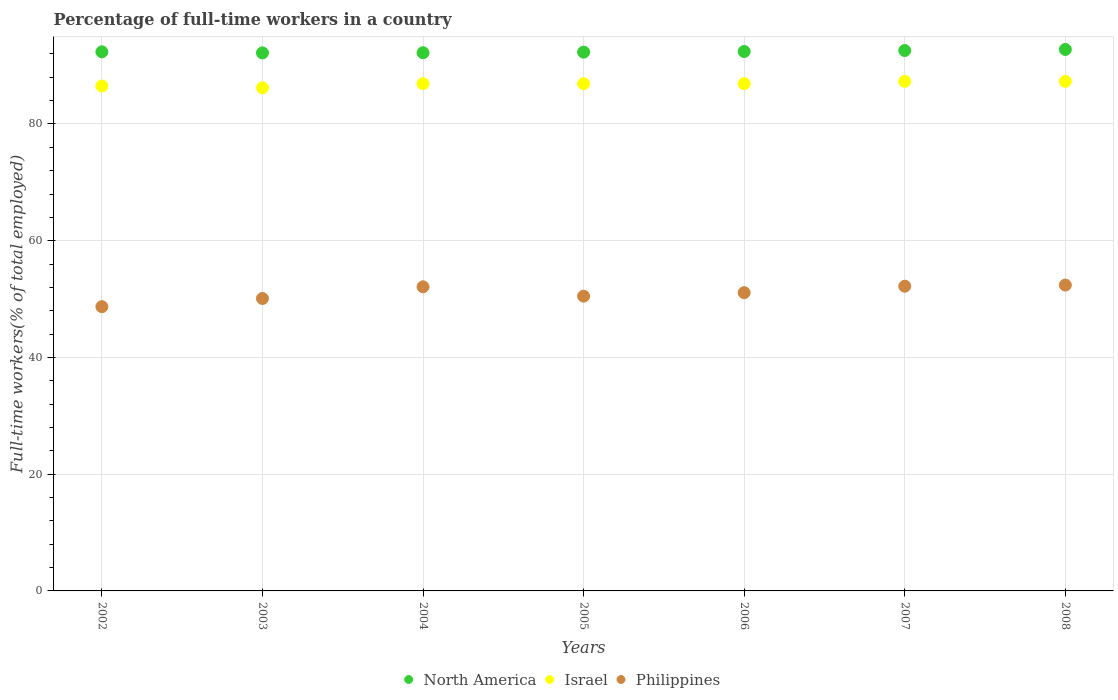Is the number of dotlines equal to the number of legend labels?
Offer a terse response. Yes. What is the percentage of full-time workers in North America in 2007?
Provide a short and direct response. 92.58. Across all years, what is the maximum percentage of full-time workers in Israel?
Your answer should be very brief. 87.3. Across all years, what is the minimum percentage of full-time workers in Philippines?
Keep it short and to the point. 48.7. In which year was the percentage of full-time workers in Israel minimum?
Make the answer very short. 2003. What is the total percentage of full-time workers in Israel in the graph?
Make the answer very short. 608. What is the difference between the percentage of full-time workers in Philippines in 2006 and that in 2007?
Your answer should be compact. -1.1. What is the difference between the percentage of full-time workers in North America in 2004 and the percentage of full-time workers in Israel in 2008?
Ensure brevity in your answer.  4.9. What is the average percentage of full-time workers in Philippines per year?
Give a very brief answer. 51.01. In the year 2003, what is the difference between the percentage of full-time workers in North America and percentage of full-time workers in Israel?
Give a very brief answer. 5.97. What is the ratio of the percentage of full-time workers in Philippines in 2003 to that in 2007?
Offer a terse response. 0.96. What is the difference between the highest and the second highest percentage of full-time workers in Israel?
Make the answer very short. 0. What is the difference between the highest and the lowest percentage of full-time workers in Israel?
Ensure brevity in your answer.  1.1. Is the sum of the percentage of full-time workers in Israel in 2004 and 2007 greater than the maximum percentage of full-time workers in Philippines across all years?
Your answer should be very brief. Yes. How many dotlines are there?
Offer a terse response. 3. How many years are there in the graph?
Offer a terse response. 7. What is the difference between two consecutive major ticks on the Y-axis?
Your response must be concise. 20. Are the values on the major ticks of Y-axis written in scientific E-notation?
Provide a succinct answer. No. Does the graph contain any zero values?
Offer a terse response. No. Where does the legend appear in the graph?
Keep it short and to the point. Bottom center. How many legend labels are there?
Offer a very short reply. 3. What is the title of the graph?
Keep it short and to the point. Percentage of full-time workers in a country. What is the label or title of the Y-axis?
Offer a terse response. Full-time workers(% of total employed). What is the Full-time workers(% of total employed) of North America in 2002?
Provide a short and direct response. 92.36. What is the Full-time workers(% of total employed) in Israel in 2002?
Your response must be concise. 86.5. What is the Full-time workers(% of total employed) of Philippines in 2002?
Your response must be concise. 48.7. What is the Full-time workers(% of total employed) of North America in 2003?
Give a very brief answer. 92.17. What is the Full-time workers(% of total employed) of Israel in 2003?
Keep it short and to the point. 86.2. What is the Full-time workers(% of total employed) of Philippines in 2003?
Offer a very short reply. 50.1. What is the Full-time workers(% of total employed) of North America in 2004?
Provide a succinct answer. 92.2. What is the Full-time workers(% of total employed) in Israel in 2004?
Offer a very short reply. 86.9. What is the Full-time workers(% of total employed) in Philippines in 2004?
Offer a terse response. 52.1. What is the Full-time workers(% of total employed) of North America in 2005?
Ensure brevity in your answer.  92.31. What is the Full-time workers(% of total employed) in Israel in 2005?
Your response must be concise. 86.9. What is the Full-time workers(% of total employed) of Philippines in 2005?
Your answer should be very brief. 50.5. What is the Full-time workers(% of total employed) in North America in 2006?
Keep it short and to the point. 92.42. What is the Full-time workers(% of total employed) of Israel in 2006?
Your answer should be compact. 86.9. What is the Full-time workers(% of total employed) in Philippines in 2006?
Give a very brief answer. 51.1. What is the Full-time workers(% of total employed) in North America in 2007?
Your answer should be compact. 92.58. What is the Full-time workers(% of total employed) of Israel in 2007?
Offer a terse response. 87.3. What is the Full-time workers(% of total employed) in Philippines in 2007?
Keep it short and to the point. 52.2. What is the Full-time workers(% of total employed) of North America in 2008?
Offer a terse response. 92.77. What is the Full-time workers(% of total employed) of Israel in 2008?
Your answer should be very brief. 87.3. What is the Full-time workers(% of total employed) of Philippines in 2008?
Give a very brief answer. 52.4. Across all years, what is the maximum Full-time workers(% of total employed) in North America?
Provide a short and direct response. 92.77. Across all years, what is the maximum Full-time workers(% of total employed) in Israel?
Your response must be concise. 87.3. Across all years, what is the maximum Full-time workers(% of total employed) in Philippines?
Provide a short and direct response. 52.4. Across all years, what is the minimum Full-time workers(% of total employed) in North America?
Ensure brevity in your answer.  92.17. Across all years, what is the minimum Full-time workers(% of total employed) of Israel?
Give a very brief answer. 86.2. Across all years, what is the minimum Full-time workers(% of total employed) in Philippines?
Your response must be concise. 48.7. What is the total Full-time workers(% of total employed) of North America in the graph?
Keep it short and to the point. 646.81. What is the total Full-time workers(% of total employed) of Israel in the graph?
Provide a short and direct response. 608. What is the total Full-time workers(% of total employed) of Philippines in the graph?
Your response must be concise. 357.1. What is the difference between the Full-time workers(% of total employed) in North America in 2002 and that in 2003?
Your answer should be very brief. 0.18. What is the difference between the Full-time workers(% of total employed) in Israel in 2002 and that in 2003?
Give a very brief answer. 0.3. What is the difference between the Full-time workers(% of total employed) in North America in 2002 and that in 2004?
Your answer should be compact. 0.15. What is the difference between the Full-time workers(% of total employed) in Philippines in 2002 and that in 2004?
Give a very brief answer. -3.4. What is the difference between the Full-time workers(% of total employed) in North America in 2002 and that in 2005?
Your response must be concise. 0.05. What is the difference between the Full-time workers(% of total employed) of Israel in 2002 and that in 2005?
Your answer should be very brief. -0.4. What is the difference between the Full-time workers(% of total employed) of Philippines in 2002 and that in 2005?
Provide a short and direct response. -1.8. What is the difference between the Full-time workers(% of total employed) in North America in 2002 and that in 2006?
Provide a short and direct response. -0.06. What is the difference between the Full-time workers(% of total employed) of Philippines in 2002 and that in 2006?
Your response must be concise. -2.4. What is the difference between the Full-time workers(% of total employed) in North America in 2002 and that in 2007?
Ensure brevity in your answer.  -0.22. What is the difference between the Full-time workers(% of total employed) of Israel in 2002 and that in 2007?
Offer a very short reply. -0.8. What is the difference between the Full-time workers(% of total employed) of Philippines in 2002 and that in 2007?
Your answer should be compact. -3.5. What is the difference between the Full-time workers(% of total employed) in North America in 2002 and that in 2008?
Ensure brevity in your answer.  -0.41. What is the difference between the Full-time workers(% of total employed) in Israel in 2002 and that in 2008?
Your answer should be compact. -0.8. What is the difference between the Full-time workers(% of total employed) in North America in 2003 and that in 2004?
Your response must be concise. -0.03. What is the difference between the Full-time workers(% of total employed) in North America in 2003 and that in 2005?
Give a very brief answer. -0.13. What is the difference between the Full-time workers(% of total employed) of Israel in 2003 and that in 2005?
Offer a terse response. -0.7. What is the difference between the Full-time workers(% of total employed) of North America in 2003 and that in 2006?
Your response must be concise. -0.24. What is the difference between the Full-time workers(% of total employed) in Philippines in 2003 and that in 2006?
Provide a short and direct response. -1. What is the difference between the Full-time workers(% of total employed) in North America in 2003 and that in 2007?
Your answer should be very brief. -0.41. What is the difference between the Full-time workers(% of total employed) in North America in 2003 and that in 2008?
Your answer should be compact. -0.59. What is the difference between the Full-time workers(% of total employed) of Israel in 2003 and that in 2008?
Offer a very short reply. -1.1. What is the difference between the Full-time workers(% of total employed) of North America in 2004 and that in 2005?
Offer a very short reply. -0.1. What is the difference between the Full-time workers(% of total employed) in Philippines in 2004 and that in 2005?
Make the answer very short. 1.6. What is the difference between the Full-time workers(% of total employed) of North America in 2004 and that in 2006?
Ensure brevity in your answer.  -0.21. What is the difference between the Full-time workers(% of total employed) in Philippines in 2004 and that in 2006?
Offer a terse response. 1. What is the difference between the Full-time workers(% of total employed) of North America in 2004 and that in 2007?
Offer a very short reply. -0.38. What is the difference between the Full-time workers(% of total employed) of North America in 2004 and that in 2008?
Ensure brevity in your answer.  -0.56. What is the difference between the Full-time workers(% of total employed) of Philippines in 2004 and that in 2008?
Keep it short and to the point. -0.3. What is the difference between the Full-time workers(% of total employed) in North America in 2005 and that in 2006?
Offer a terse response. -0.11. What is the difference between the Full-time workers(% of total employed) of North America in 2005 and that in 2007?
Your response must be concise. -0.28. What is the difference between the Full-time workers(% of total employed) in Philippines in 2005 and that in 2007?
Keep it short and to the point. -1.7. What is the difference between the Full-time workers(% of total employed) of North America in 2005 and that in 2008?
Offer a terse response. -0.46. What is the difference between the Full-time workers(% of total employed) in Israel in 2005 and that in 2008?
Provide a succinct answer. -0.4. What is the difference between the Full-time workers(% of total employed) in North America in 2006 and that in 2007?
Your response must be concise. -0.17. What is the difference between the Full-time workers(% of total employed) in Philippines in 2006 and that in 2007?
Keep it short and to the point. -1.1. What is the difference between the Full-time workers(% of total employed) in North America in 2006 and that in 2008?
Offer a terse response. -0.35. What is the difference between the Full-time workers(% of total employed) of Israel in 2006 and that in 2008?
Give a very brief answer. -0.4. What is the difference between the Full-time workers(% of total employed) of North America in 2007 and that in 2008?
Keep it short and to the point. -0.19. What is the difference between the Full-time workers(% of total employed) in Israel in 2007 and that in 2008?
Ensure brevity in your answer.  0. What is the difference between the Full-time workers(% of total employed) of Philippines in 2007 and that in 2008?
Offer a very short reply. -0.2. What is the difference between the Full-time workers(% of total employed) of North America in 2002 and the Full-time workers(% of total employed) of Israel in 2003?
Give a very brief answer. 6.16. What is the difference between the Full-time workers(% of total employed) of North America in 2002 and the Full-time workers(% of total employed) of Philippines in 2003?
Provide a short and direct response. 42.26. What is the difference between the Full-time workers(% of total employed) in Israel in 2002 and the Full-time workers(% of total employed) in Philippines in 2003?
Your response must be concise. 36.4. What is the difference between the Full-time workers(% of total employed) in North America in 2002 and the Full-time workers(% of total employed) in Israel in 2004?
Provide a succinct answer. 5.46. What is the difference between the Full-time workers(% of total employed) of North America in 2002 and the Full-time workers(% of total employed) of Philippines in 2004?
Your answer should be compact. 40.26. What is the difference between the Full-time workers(% of total employed) of Israel in 2002 and the Full-time workers(% of total employed) of Philippines in 2004?
Your answer should be compact. 34.4. What is the difference between the Full-time workers(% of total employed) in North America in 2002 and the Full-time workers(% of total employed) in Israel in 2005?
Give a very brief answer. 5.46. What is the difference between the Full-time workers(% of total employed) of North America in 2002 and the Full-time workers(% of total employed) of Philippines in 2005?
Give a very brief answer. 41.86. What is the difference between the Full-time workers(% of total employed) in Israel in 2002 and the Full-time workers(% of total employed) in Philippines in 2005?
Give a very brief answer. 36. What is the difference between the Full-time workers(% of total employed) in North America in 2002 and the Full-time workers(% of total employed) in Israel in 2006?
Your answer should be very brief. 5.46. What is the difference between the Full-time workers(% of total employed) of North America in 2002 and the Full-time workers(% of total employed) of Philippines in 2006?
Your response must be concise. 41.26. What is the difference between the Full-time workers(% of total employed) in Israel in 2002 and the Full-time workers(% of total employed) in Philippines in 2006?
Provide a short and direct response. 35.4. What is the difference between the Full-time workers(% of total employed) in North America in 2002 and the Full-time workers(% of total employed) in Israel in 2007?
Provide a short and direct response. 5.06. What is the difference between the Full-time workers(% of total employed) of North America in 2002 and the Full-time workers(% of total employed) of Philippines in 2007?
Give a very brief answer. 40.16. What is the difference between the Full-time workers(% of total employed) in Israel in 2002 and the Full-time workers(% of total employed) in Philippines in 2007?
Provide a short and direct response. 34.3. What is the difference between the Full-time workers(% of total employed) in North America in 2002 and the Full-time workers(% of total employed) in Israel in 2008?
Your answer should be compact. 5.06. What is the difference between the Full-time workers(% of total employed) of North America in 2002 and the Full-time workers(% of total employed) of Philippines in 2008?
Your answer should be compact. 39.96. What is the difference between the Full-time workers(% of total employed) of Israel in 2002 and the Full-time workers(% of total employed) of Philippines in 2008?
Provide a short and direct response. 34.1. What is the difference between the Full-time workers(% of total employed) of North America in 2003 and the Full-time workers(% of total employed) of Israel in 2004?
Offer a very short reply. 5.27. What is the difference between the Full-time workers(% of total employed) of North America in 2003 and the Full-time workers(% of total employed) of Philippines in 2004?
Your answer should be very brief. 40.07. What is the difference between the Full-time workers(% of total employed) of Israel in 2003 and the Full-time workers(% of total employed) of Philippines in 2004?
Provide a short and direct response. 34.1. What is the difference between the Full-time workers(% of total employed) of North America in 2003 and the Full-time workers(% of total employed) of Israel in 2005?
Make the answer very short. 5.27. What is the difference between the Full-time workers(% of total employed) of North America in 2003 and the Full-time workers(% of total employed) of Philippines in 2005?
Your answer should be compact. 41.67. What is the difference between the Full-time workers(% of total employed) of Israel in 2003 and the Full-time workers(% of total employed) of Philippines in 2005?
Provide a succinct answer. 35.7. What is the difference between the Full-time workers(% of total employed) of North America in 2003 and the Full-time workers(% of total employed) of Israel in 2006?
Your answer should be compact. 5.27. What is the difference between the Full-time workers(% of total employed) in North America in 2003 and the Full-time workers(% of total employed) in Philippines in 2006?
Keep it short and to the point. 41.07. What is the difference between the Full-time workers(% of total employed) of Israel in 2003 and the Full-time workers(% of total employed) of Philippines in 2006?
Ensure brevity in your answer.  35.1. What is the difference between the Full-time workers(% of total employed) of North America in 2003 and the Full-time workers(% of total employed) of Israel in 2007?
Offer a terse response. 4.87. What is the difference between the Full-time workers(% of total employed) of North America in 2003 and the Full-time workers(% of total employed) of Philippines in 2007?
Give a very brief answer. 39.97. What is the difference between the Full-time workers(% of total employed) of North America in 2003 and the Full-time workers(% of total employed) of Israel in 2008?
Provide a short and direct response. 4.87. What is the difference between the Full-time workers(% of total employed) in North America in 2003 and the Full-time workers(% of total employed) in Philippines in 2008?
Provide a short and direct response. 39.77. What is the difference between the Full-time workers(% of total employed) in Israel in 2003 and the Full-time workers(% of total employed) in Philippines in 2008?
Keep it short and to the point. 33.8. What is the difference between the Full-time workers(% of total employed) of North America in 2004 and the Full-time workers(% of total employed) of Israel in 2005?
Your answer should be very brief. 5.3. What is the difference between the Full-time workers(% of total employed) in North America in 2004 and the Full-time workers(% of total employed) in Philippines in 2005?
Give a very brief answer. 41.7. What is the difference between the Full-time workers(% of total employed) of Israel in 2004 and the Full-time workers(% of total employed) of Philippines in 2005?
Keep it short and to the point. 36.4. What is the difference between the Full-time workers(% of total employed) of North America in 2004 and the Full-time workers(% of total employed) of Israel in 2006?
Your answer should be very brief. 5.3. What is the difference between the Full-time workers(% of total employed) in North America in 2004 and the Full-time workers(% of total employed) in Philippines in 2006?
Your answer should be very brief. 41.1. What is the difference between the Full-time workers(% of total employed) of Israel in 2004 and the Full-time workers(% of total employed) of Philippines in 2006?
Your answer should be compact. 35.8. What is the difference between the Full-time workers(% of total employed) of North America in 2004 and the Full-time workers(% of total employed) of Israel in 2007?
Offer a terse response. 4.9. What is the difference between the Full-time workers(% of total employed) of North America in 2004 and the Full-time workers(% of total employed) of Philippines in 2007?
Provide a succinct answer. 40. What is the difference between the Full-time workers(% of total employed) of Israel in 2004 and the Full-time workers(% of total employed) of Philippines in 2007?
Make the answer very short. 34.7. What is the difference between the Full-time workers(% of total employed) in North America in 2004 and the Full-time workers(% of total employed) in Israel in 2008?
Offer a terse response. 4.9. What is the difference between the Full-time workers(% of total employed) in North America in 2004 and the Full-time workers(% of total employed) in Philippines in 2008?
Your response must be concise. 39.8. What is the difference between the Full-time workers(% of total employed) in Israel in 2004 and the Full-time workers(% of total employed) in Philippines in 2008?
Make the answer very short. 34.5. What is the difference between the Full-time workers(% of total employed) of North America in 2005 and the Full-time workers(% of total employed) of Israel in 2006?
Your answer should be very brief. 5.41. What is the difference between the Full-time workers(% of total employed) in North America in 2005 and the Full-time workers(% of total employed) in Philippines in 2006?
Provide a succinct answer. 41.21. What is the difference between the Full-time workers(% of total employed) of Israel in 2005 and the Full-time workers(% of total employed) of Philippines in 2006?
Keep it short and to the point. 35.8. What is the difference between the Full-time workers(% of total employed) in North America in 2005 and the Full-time workers(% of total employed) in Israel in 2007?
Keep it short and to the point. 5.01. What is the difference between the Full-time workers(% of total employed) in North America in 2005 and the Full-time workers(% of total employed) in Philippines in 2007?
Offer a very short reply. 40.11. What is the difference between the Full-time workers(% of total employed) of Israel in 2005 and the Full-time workers(% of total employed) of Philippines in 2007?
Offer a terse response. 34.7. What is the difference between the Full-time workers(% of total employed) of North America in 2005 and the Full-time workers(% of total employed) of Israel in 2008?
Offer a very short reply. 5.01. What is the difference between the Full-time workers(% of total employed) in North America in 2005 and the Full-time workers(% of total employed) in Philippines in 2008?
Give a very brief answer. 39.91. What is the difference between the Full-time workers(% of total employed) in Israel in 2005 and the Full-time workers(% of total employed) in Philippines in 2008?
Provide a succinct answer. 34.5. What is the difference between the Full-time workers(% of total employed) in North America in 2006 and the Full-time workers(% of total employed) in Israel in 2007?
Your answer should be compact. 5.12. What is the difference between the Full-time workers(% of total employed) of North America in 2006 and the Full-time workers(% of total employed) of Philippines in 2007?
Ensure brevity in your answer.  40.22. What is the difference between the Full-time workers(% of total employed) in Israel in 2006 and the Full-time workers(% of total employed) in Philippines in 2007?
Provide a short and direct response. 34.7. What is the difference between the Full-time workers(% of total employed) in North America in 2006 and the Full-time workers(% of total employed) in Israel in 2008?
Keep it short and to the point. 5.12. What is the difference between the Full-time workers(% of total employed) in North America in 2006 and the Full-time workers(% of total employed) in Philippines in 2008?
Offer a terse response. 40.02. What is the difference between the Full-time workers(% of total employed) in Israel in 2006 and the Full-time workers(% of total employed) in Philippines in 2008?
Offer a very short reply. 34.5. What is the difference between the Full-time workers(% of total employed) in North America in 2007 and the Full-time workers(% of total employed) in Israel in 2008?
Provide a short and direct response. 5.28. What is the difference between the Full-time workers(% of total employed) in North America in 2007 and the Full-time workers(% of total employed) in Philippines in 2008?
Keep it short and to the point. 40.18. What is the difference between the Full-time workers(% of total employed) of Israel in 2007 and the Full-time workers(% of total employed) of Philippines in 2008?
Your response must be concise. 34.9. What is the average Full-time workers(% of total employed) in North America per year?
Make the answer very short. 92.4. What is the average Full-time workers(% of total employed) of Israel per year?
Make the answer very short. 86.86. What is the average Full-time workers(% of total employed) of Philippines per year?
Your answer should be compact. 51.01. In the year 2002, what is the difference between the Full-time workers(% of total employed) in North America and Full-time workers(% of total employed) in Israel?
Make the answer very short. 5.86. In the year 2002, what is the difference between the Full-time workers(% of total employed) of North America and Full-time workers(% of total employed) of Philippines?
Your response must be concise. 43.66. In the year 2002, what is the difference between the Full-time workers(% of total employed) in Israel and Full-time workers(% of total employed) in Philippines?
Keep it short and to the point. 37.8. In the year 2003, what is the difference between the Full-time workers(% of total employed) of North America and Full-time workers(% of total employed) of Israel?
Your response must be concise. 5.97. In the year 2003, what is the difference between the Full-time workers(% of total employed) of North America and Full-time workers(% of total employed) of Philippines?
Provide a succinct answer. 42.07. In the year 2003, what is the difference between the Full-time workers(% of total employed) of Israel and Full-time workers(% of total employed) of Philippines?
Your answer should be very brief. 36.1. In the year 2004, what is the difference between the Full-time workers(% of total employed) in North America and Full-time workers(% of total employed) in Israel?
Offer a very short reply. 5.3. In the year 2004, what is the difference between the Full-time workers(% of total employed) of North America and Full-time workers(% of total employed) of Philippines?
Your answer should be compact. 40.1. In the year 2004, what is the difference between the Full-time workers(% of total employed) of Israel and Full-time workers(% of total employed) of Philippines?
Your answer should be very brief. 34.8. In the year 2005, what is the difference between the Full-time workers(% of total employed) of North America and Full-time workers(% of total employed) of Israel?
Provide a succinct answer. 5.41. In the year 2005, what is the difference between the Full-time workers(% of total employed) in North America and Full-time workers(% of total employed) in Philippines?
Provide a short and direct response. 41.81. In the year 2005, what is the difference between the Full-time workers(% of total employed) of Israel and Full-time workers(% of total employed) of Philippines?
Give a very brief answer. 36.4. In the year 2006, what is the difference between the Full-time workers(% of total employed) in North America and Full-time workers(% of total employed) in Israel?
Keep it short and to the point. 5.52. In the year 2006, what is the difference between the Full-time workers(% of total employed) of North America and Full-time workers(% of total employed) of Philippines?
Ensure brevity in your answer.  41.32. In the year 2006, what is the difference between the Full-time workers(% of total employed) in Israel and Full-time workers(% of total employed) in Philippines?
Your answer should be compact. 35.8. In the year 2007, what is the difference between the Full-time workers(% of total employed) in North America and Full-time workers(% of total employed) in Israel?
Offer a very short reply. 5.28. In the year 2007, what is the difference between the Full-time workers(% of total employed) of North America and Full-time workers(% of total employed) of Philippines?
Provide a short and direct response. 40.38. In the year 2007, what is the difference between the Full-time workers(% of total employed) of Israel and Full-time workers(% of total employed) of Philippines?
Provide a succinct answer. 35.1. In the year 2008, what is the difference between the Full-time workers(% of total employed) in North America and Full-time workers(% of total employed) in Israel?
Offer a very short reply. 5.47. In the year 2008, what is the difference between the Full-time workers(% of total employed) of North America and Full-time workers(% of total employed) of Philippines?
Keep it short and to the point. 40.37. In the year 2008, what is the difference between the Full-time workers(% of total employed) in Israel and Full-time workers(% of total employed) in Philippines?
Offer a very short reply. 34.9. What is the ratio of the Full-time workers(% of total employed) in Philippines in 2002 to that in 2003?
Keep it short and to the point. 0.97. What is the ratio of the Full-time workers(% of total employed) in North America in 2002 to that in 2004?
Provide a short and direct response. 1. What is the ratio of the Full-time workers(% of total employed) of Israel in 2002 to that in 2004?
Ensure brevity in your answer.  1. What is the ratio of the Full-time workers(% of total employed) in Philippines in 2002 to that in 2004?
Your answer should be compact. 0.93. What is the ratio of the Full-time workers(% of total employed) of North America in 2002 to that in 2005?
Provide a succinct answer. 1. What is the ratio of the Full-time workers(% of total employed) in Israel in 2002 to that in 2005?
Provide a succinct answer. 1. What is the ratio of the Full-time workers(% of total employed) in Philippines in 2002 to that in 2005?
Your response must be concise. 0.96. What is the ratio of the Full-time workers(% of total employed) of Israel in 2002 to that in 2006?
Offer a very short reply. 1. What is the ratio of the Full-time workers(% of total employed) in Philippines in 2002 to that in 2006?
Your answer should be compact. 0.95. What is the ratio of the Full-time workers(% of total employed) in Israel in 2002 to that in 2007?
Your answer should be compact. 0.99. What is the ratio of the Full-time workers(% of total employed) in Philippines in 2002 to that in 2007?
Offer a terse response. 0.93. What is the ratio of the Full-time workers(% of total employed) in Philippines in 2002 to that in 2008?
Offer a terse response. 0.93. What is the ratio of the Full-time workers(% of total employed) in North America in 2003 to that in 2004?
Make the answer very short. 1. What is the ratio of the Full-time workers(% of total employed) of Israel in 2003 to that in 2004?
Provide a succinct answer. 0.99. What is the ratio of the Full-time workers(% of total employed) in Philippines in 2003 to that in 2004?
Your response must be concise. 0.96. What is the ratio of the Full-time workers(% of total employed) of North America in 2003 to that in 2005?
Keep it short and to the point. 1. What is the ratio of the Full-time workers(% of total employed) of Israel in 2003 to that in 2005?
Make the answer very short. 0.99. What is the ratio of the Full-time workers(% of total employed) in North America in 2003 to that in 2006?
Keep it short and to the point. 1. What is the ratio of the Full-time workers(% of total employed) of Israel in 2003 to that in 2006?
Offer a very short reply. 0.99. What is the ratio of the Full-time workers(% of total employed) of Philippines in 2003 to that in 2006?
Make the answer very short. 0.98. What is the ratio of the Full-time workers(% of total employed) of North America in 2003 to that in 2007?
Offer a terse response. 1. What is the ratio of the Full-time workers(% of total employed) of Israel in 2003 to that in 2007?
Provide a short and direct response. 0.99. What is the ratio of the Full-time workers(% of total employed) in Philippines in 2003 to that in 2007?
Keep it short and to the point. 0.96. What is the ratio of the Full-time workers(% of total employed) in North America in 2003 to that in 2008?
Offer a terse response. 0.99. What is the ratio of the Full-time workers(% of total employed) in Israel in 2003 to that in 2008?
Offer a terse response. 0.99. What is the ratio of the Full-time workers(% of total employed) of Philippines in 2003 to that in 2008?
Keep it short and to the point. 0.96. What is the ratio of the Full-time workers(% of total employed) in North America in 2004 to that in 2005?
Ensure brevity in your answer.  1. What is the ratio of the Full-time workers(% of total employed) in Philippines in 2004 to that in 2005?
Keep it short and to the point. 1.03. What is the ratio of the Full-time workers(% of total employed) of Philippines in 2004 to that in 2006?
Give a very brief answer. 1.02. What is the ratio of the Full-time workers(% of total employed) of Israel in 2004 to that in 2007?
Ensure brevity in your answer.  1. What is the ratio of the Full-time workers(% of total employed) of Philippines in 2004 to that in 2007?
Provide a succinct answer. 1. What is the ratio of the Full-time workers(% of total employed) of Israel in 2004 to that in 2008?
Make the answer very short. 1. What is the ratio of the Full-time workers(% of total employed) in Philippines in 2005 to that in 2006?
Keep it short and to the point. 0.99. What is the ratio of the Full-time workers(% of total employed) in Philippines in 2005 to that in 2007?
Provide a succinct answer. 0.97. What is the ratio of the Full-time workers(% of total employed) of Philippines in 2005 to that in 2008?
Provide a succinct answer. 0.96. What is the ratio of the Full-time workers(% of total employed) in Philippines in 2006 to that in 2007?
Provide a succinct answer. 0.98. What is the ratio of the Full-time workers(% of total employed) in Philippines in 2006 to that in 2008?
Provide a succinct answer. 0.98. What is the ratio of the Full-time workers(% of total employed) of North America in 2007 to that in 2008?
Offer a terse response. 1. What is the ratio of the Full-time workers(% of total employed) in Israel in 2007 to that in 2008?
Your answer should be very brief. 1. What is the difference between the highest and the second highest Full-time workers(% of total employed) of North America?
Offer a terse response. 0.19. What is the difference between the highest and the second highest Full-time workers(% of total employed) of Israel?
Ensure brevity in your answer.  0. What is the difference between the highest and the lowest Full-time workers(% of total employed) in North America?
Ensure brevity in your answer.  0.59. What is the difference between the highest and the lowest Full-time workers(% of total employed) in Philippines?
Keep it short and to the point. 3.7. 